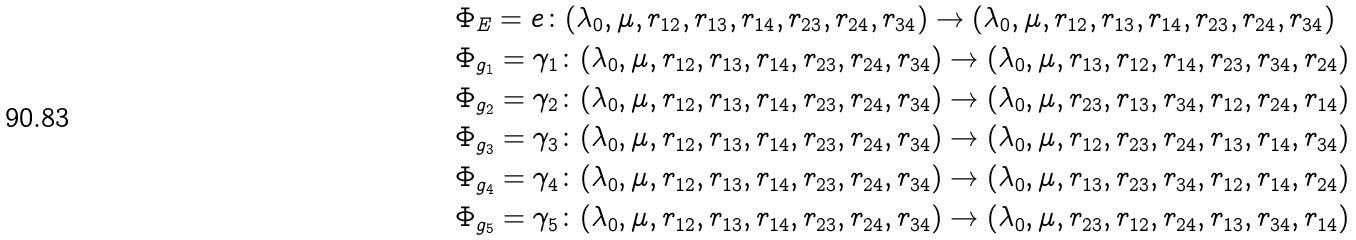Convert formula to latex. <formula><loc_0><loc_0><loc_500><loc_500>& \Phi _ { E } = e \colon ( \lambda _ { 0 } , \mu , r _ { 1 2 } , r _ { 1 3 } , r _ { 1 4 } , r _ { 2 3 } , r _ { 2 4 } , r _ { 3 4 } ) \rightarrow ( \lambda _ { 0 } , \mu , r _ { 1 2 } , r _ { 1 3 } , r _ { 1 4 } , r _ { 2 3 } , r _ { 2 4 } , r _ { 3 4 } ) \\ & \Phi _ { g _ { 1 } } = \gamma _ { 1 } \colon ( \lambda _ { 0 } , \mu , r _ { 1 2 } , r _ { 1 3 } , r _ { 1 4 } , r _ { 2 3 } , r _ { 2 4 } , r _ { 3 4 } ) \rightarrow ( \lambda _ { 0 } , \mu , r _ { 1 3 } , r _ { 1 2 } , r _ { 1 4 } , r _ { 2 3 } , r _ { 3 4 } , r _ { 2 4 } ) \\ & \Phi _ { g _ { 2 } } = \gamma _ { 2 } \colon ( \lambda _ { 0 } , \mu , r _ { 1 2 } , r _ { 1 3 } , r _ { 1 4 } , r _ { 2 3 } , r _ { 2 4 } , r _ { 3 4 } ) \rightarrow ( \lambda _ { 0 } , \mu , r _ { 2 3 } , r _ { 1 3 } , r _ { 3 4 } , r _ { 1 2 } , r _ { 2 4 } , r _ { 1 4 } ) \\ & \Phi _ { g _ { 3 } } = \gamma _ { 3 } \colon ( \lambda _ { 0 } , \mu , r _ { 1 2 } , r _ { 1 3 } , r _ { 1 4 } , r _ { 2 3 } , r _ { 2 4 } , r _ { 3 4 } ) \rightarrow ( \lambda _ { 0 } , \mu , r _ { 1 2 } , r _ { 2 3 } , r _ { 2 4 } , r _ { 1 3 } , r _ { 1 4 } , r _ { 3 4 } ) \\ & \Phi _ { g _ { 4 } } = \gamma _ { 4 } \colon ( \lambda _ { 0 } , \mu , r _ { 1 2 } , r _ { 1 3 } , r _ { 1 4 } , r _ { 2 3 } , r _ { 2 4 } , r _ { 3 4 } ) \rightarrow ( \lambda _ { 0 } , \mu , r _ { 1 3 } , r _ { 2 3 } , r _ { 3 4 } , r _ { 1 2 } , r _ { 1 4 } , r _ { 2 4 } ) \\ & \Phi _ { g _ { 5 } } = \gamma _ { 5 } \colon ( \lambda _ { 0 } , \mu , r _ { 1 2 } , r _ { 1 3 } , r _ { 1 4 } , r _ { 2 3 } , r _ { 2 4 } , r _ { 3 4 } ) \rightarrow ( \lambda _ { 0 } , \mu , r _ { 2 3 } , r _ { 1 2 } , r _ { 2 4 } , r _ { 1 3 } , r _ { 3 4 } , r _ { 1 4 } ) \\</formula> 